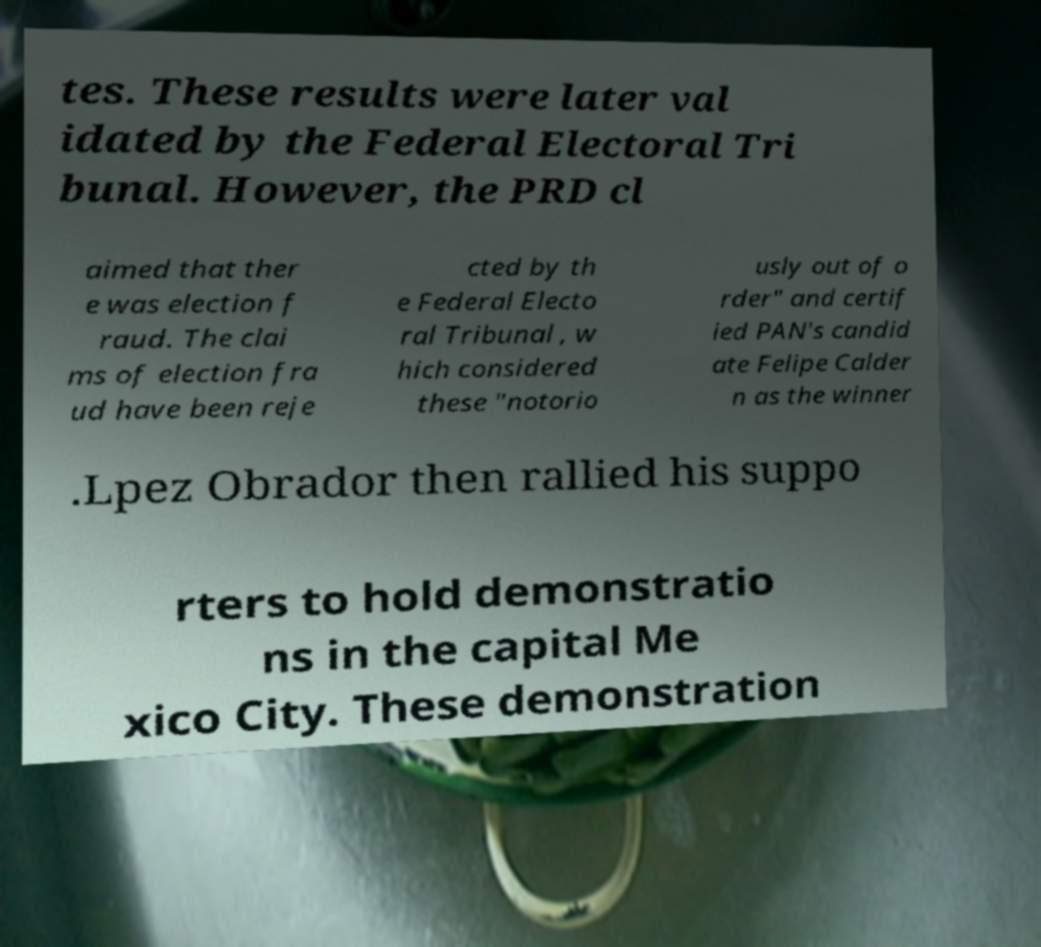I need the written content from this picture converted into text. Can you do that? tes. These results were later val idated by the Federal Electoral Tri bunal. However, the PRD cl aimed that ther e was election f raud. The clai ms of election fra ud have been reje cted by th e Federal Electo ral Tribunal , w hich considered these "notorio usly out of o rder" and certif ied PAN's candid ate Felipe Calder n as the winner .Lpez Obrador then rallied his suppo rters to hold demonstratio ns in the capital Me xico City. These demonstration 